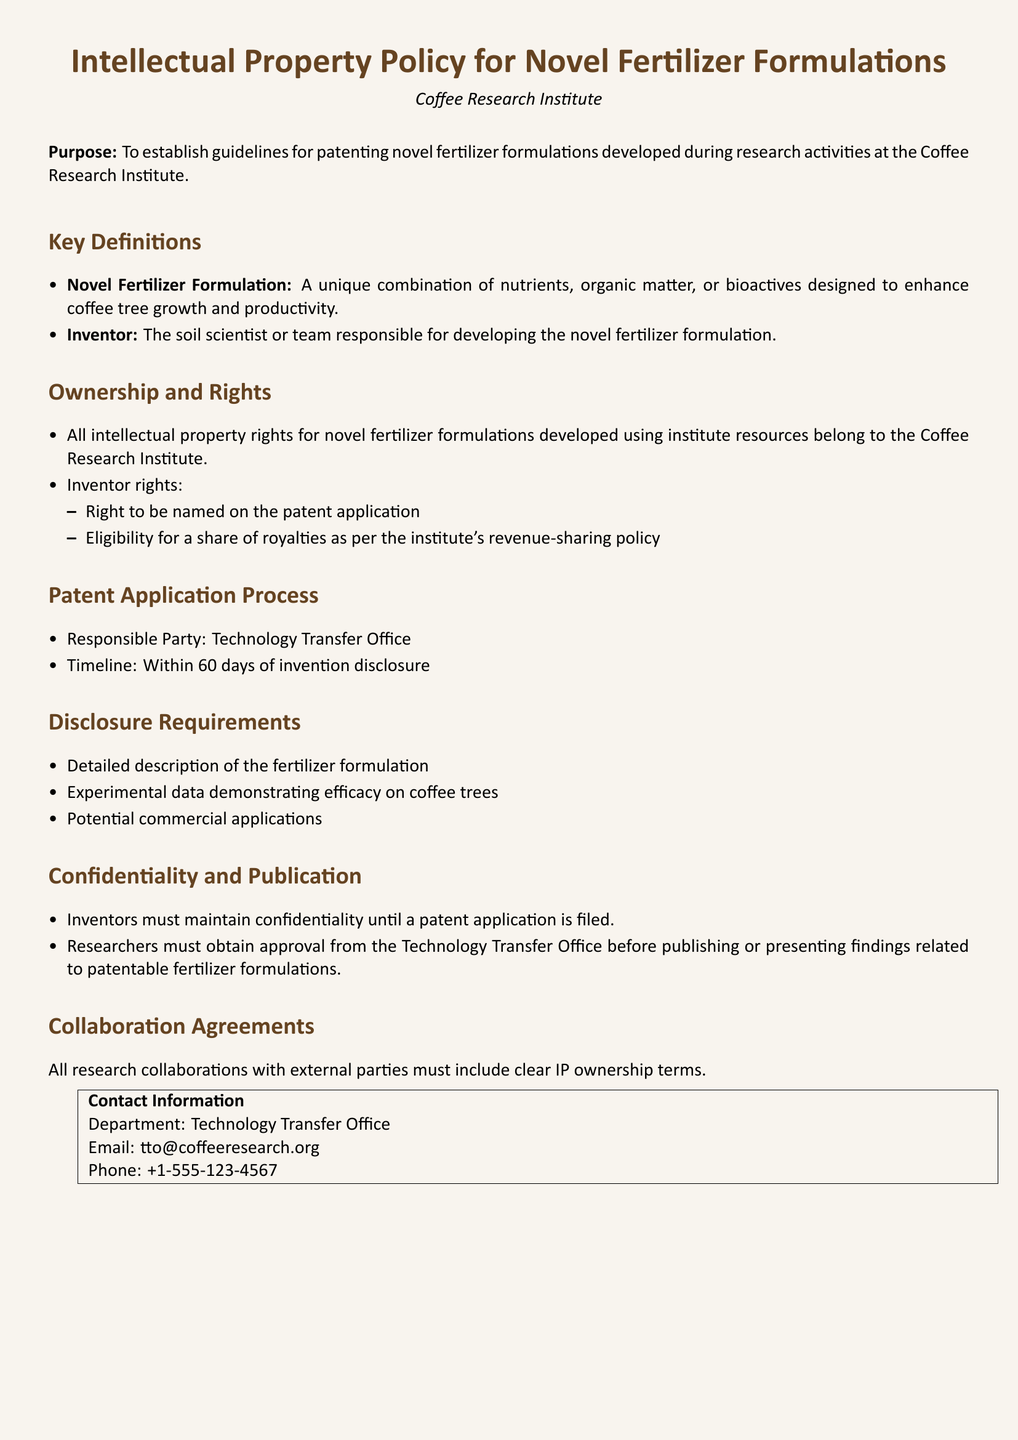What is the purpose of the document? The purpose is outlined at the beginning of the document and it establishes guidelines for patenting novel fertilizer formulations developed during research activities.
Answer: To establish guidelines for patenting novel fertilizer formulations developed during research activities at the Coffee Research Institute Who is referred to as the inventor in the document? The document defines 'Inventor' as the individual or team responsible for developing the novel fertilizer formulation.
Answer: The soil scientist or team What is the timeline for the patent application process? The timeline for the patent application process is specified in the document and is measured in days.
Answer: Within 60 days What must inventors maintain until a patent application is filed? The document specifies the requirement regarding confidentiality prior to filing a patent application.
Answer: Confidentiality Which department is responsible for the patent application process? The document names the responsible party for the patent application process.
Answer: Technology Transfer Office What information is required in the disclosure? The document lists specific requirements for the disclosure of the fertilizer formulation and its details.
Answer: Detailed description of the fertilizer formulation What must be obtained before publishing related findings? The document states a requirement for researchers before they publish findings.
Answer: Approval from the Technology Transfer Office What must all research collaborations include? The document mentions a requirement for all research collaborations regarding intellectual property.
Answer: Clear IP ownership terms 